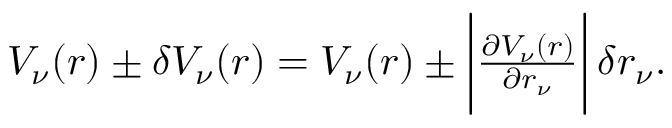<formula> <loc_0><loc_0><loc_500><loc_500>\begin{array} { r } { V _ { \nu } ( r ) \pm \delta V _ { \nu } ( r ) = V _ { \nu } ( r ) \pm \left | \frac { \partial V _ { \nu } ( r ) } { \partial r _ { \nu } } \right | \, \delta r _ { \nu } . } \end{array}</formula> 